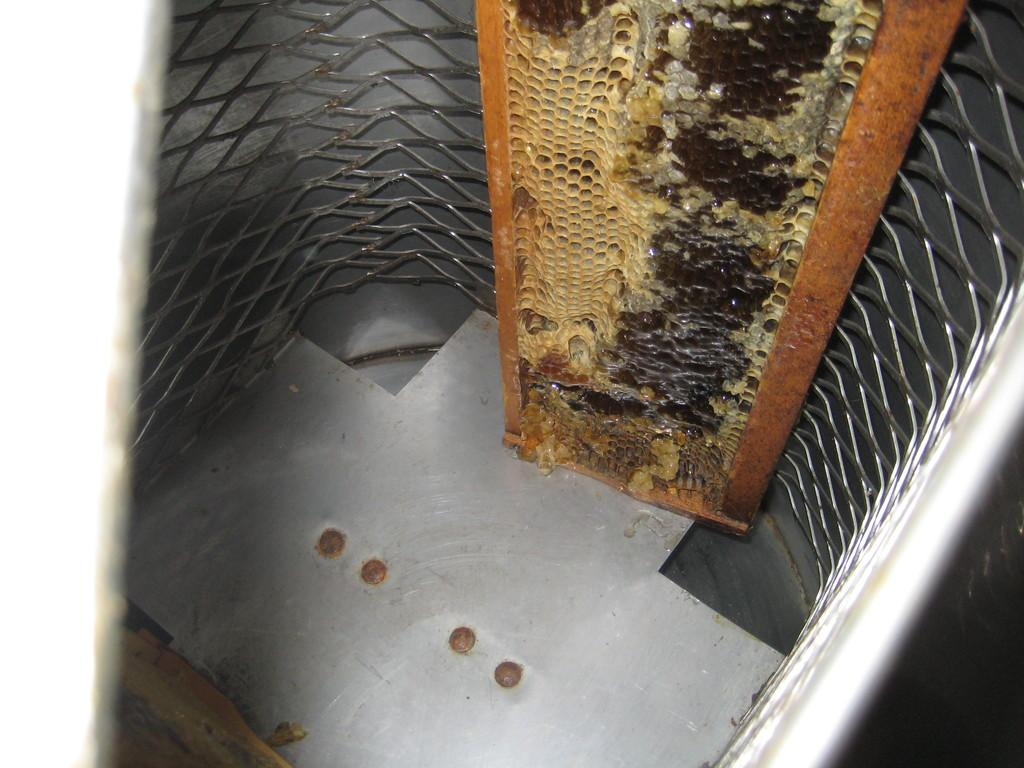What is the main subject of the image? The main subject of the image is a honeycomb. Where is the honeycomb placed? The honeycomb is placed on a steel surface. What is the surrounding environment of the steel surface? The steel surface is inside a metal fence. What type of scarf is draped over the honeycomb in the image? There is no scarf present in the image; it only features a honeycomb on a steel surface inside a metal fence. 